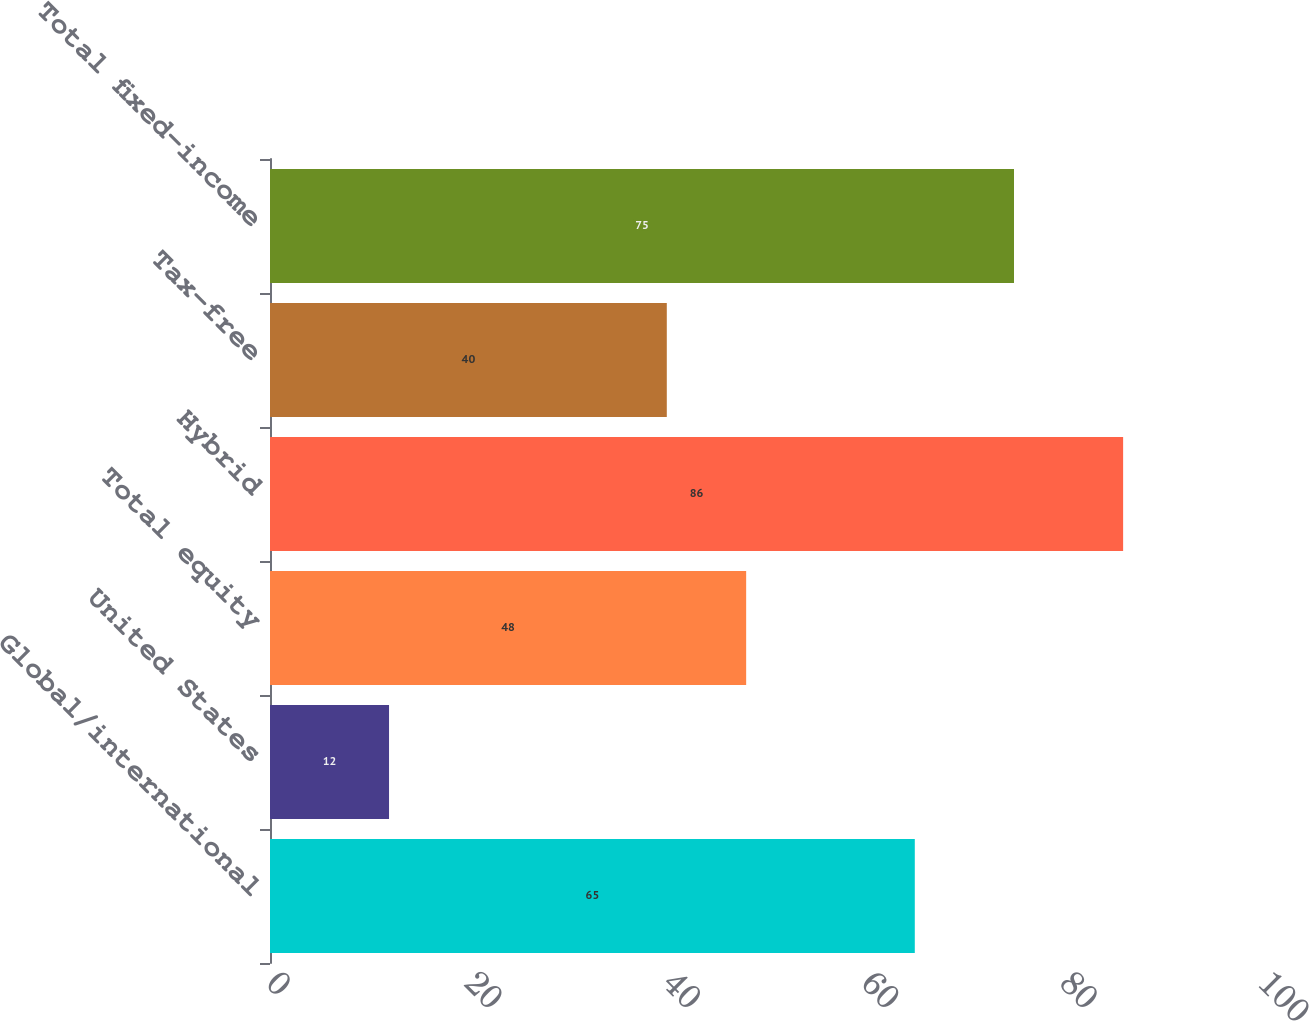<chart> <loc_0><loc_0><loc_500><loc_500><bar_chart><fcel>Global/international<fcel>United States<fcel>Total equity<fcel>Hybrid<fcel>Tax-free<fcel>Total fixed-income<nl><fcel>65<fcel>12<fcel>48<fcel>86<fcel>40<fcel>75<nl></chart> 